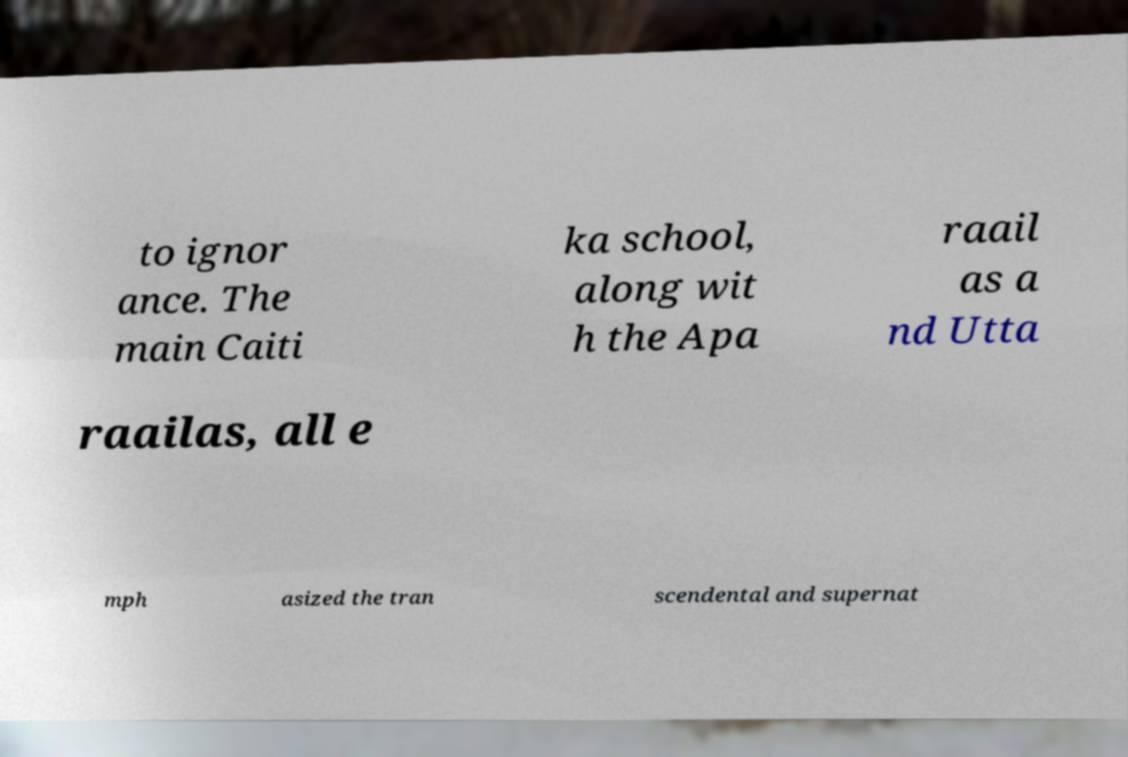What messages or text are displayed in this image? I need them in a readable, typed format. to ignor ance. The main Caiti ka school, along wit h the Apa raail as a nd Utta raailas, all e mph asized the tran scendental and supernat 